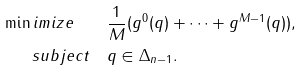Convert formula to latex. <formula><loc_0><loc_0><loc_500><loc_500>\min i m i z e \quad & \frac { 1 } { M } ( g ^ { 0 } ( q ) + \dots + g ^ { M - 1 } ( q ) ) , \\ \ s u b j e c t \quad & q \in \Delta _ { n - 1 } .</formula> 